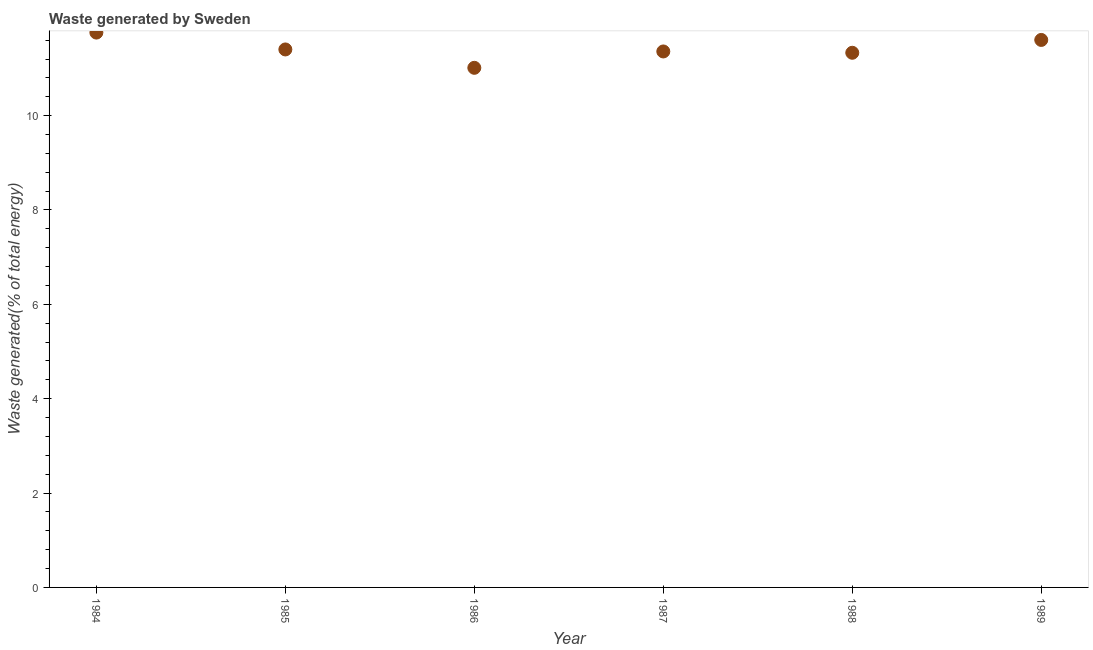What is the amount of waste generated in 1988?
Provide a succinct answer. 11.33. Across all years, what is the maximum amount of waste generated?
Keep it short and to the point. 11.76. Across all years, what is the minimum amount of waste generated?
Your response must be concise. 11.01. In which year was the amount of waste generated maximum?
Give a very brief answer. 1984. In which year was the amount of waste generated minimum?
Offer a terse response. 1986. What is the sum of the amount of waste generated?
Keep it short and to the point. 68.47. What is the difference between the amount of waste generated in 1987 and 1988?
Your answer should be compact. 0.03. What is the average amount of waste generated per year?
Keep it short and to the point. 11.41. What is the median amount of waste generated?
Ensure brevity in your answer.  11.38. Do a majority of the years between 1984 and 1987 (inclusive) have amount of waste generated greater than 0.4 %?
Your answer should be compact. Yes. What is the ratio of the amount of waste generated in 1985 to that in 1989?
Offer a very short reply. 0.98. Is the amount of waste generated in 1984 less than that in 1989?
Your response must be concise. No. What is the difference between the highest and the second highest amount of waste generated?
Your response must be concise. 0.16. What is the difference between the highest and the lowest amount of waste generated?
Offer a very short reply. 0.75. How many years are there in the graph?
Offer a terse response. 6. Does the graph contain any zero values?
Ensure brevity in your answer.  No. Does the graph contain grids?
Your response must be concise. No. What is the title of the graph?
Ensure brevity in your answer.  Waste generated by Sweden. What is the label or title of the X-axis?
Offer a very short reply. Year. What is the label or title of the Y-axis?
Your response must be concise. Waste generated(% of total energy). What is the Waste generated(% of total energy) in 1984?
Provide a short and direct response. 11.76. What is the Waste generated(% of total energy) in 1985?
Provide a short and direct response. 11.4. What is the Waste generated(% of total energy) in 1986?
Your answer should be very brief. 11.01. What is the Waste generated(% of total energy) in 1987?
Offer a terse response. 11.36. What is the Waste generated(% of total energy) in 1988?
Provide a succinct answer. 11.33. What is the Waste generated(% of total energy) in 1989?
Ensure brevity in your answer.  11.6. What is the difference between the Waste generated(% of total energy) in 1984 and 1985?
Provide a short and direct response. 0.36. What is the difference between the Waste generated(% of total energy) in 1984 and 1986?
Provide a short and direct response. 0.75. What is the difference between the Waste generated(% of total energy) in 1984 and 1987?
Give a very brief answer. 0.4. What is the difference between the Waste generated(% of total energy) in 1984 and 1988?
Offer a terse response. 0.43. What is the difference between the Waste generated(% of total energy) in 1984 and 1989?
Keep it short and to the point. 0.16. What is the difference between the Waste generated(% of total energy) in 1985 and 1986?
Provide a short and direct response. 0.39. What is the difference between the Waste generated(% of total energy) in 1985 and 1987?
Make the answer very short. 0.04. What is the difference between the Waste generated(% of total energy) in 1985 and 1988?
Provide a short and direct response. 0.07. What is the difference between the Waste generated(% of total energy) in 1985 and 1989?
Keep it short and to the point. -0.2. What is the difference between the Waste generated(% of total energy) in 1986 and 1987?
Ensure brevity in your answer.  -0.35. What is the difference between the Waste generated(% of total energy) in 1986 and 1988?
Provide a short and direct response. -0.32. What is the difference between the Waste generated(% of total energy) in 1986 and 1989?
Keep it short and to the point. -0.59. What is the difference between the Waste generated(% of total energy) in 1987 and 1988?
Offer a very short reply. 0.03. What is the difference between the Waste generated(% of total energy) in 1987 and 1989?
Offer a terse response. -0.24. What is the difference between the Waste generated(% of total energy) in 1988 and 1989?
Your response must be concise. -0.27. What is the ratio of the Waste generated(% of total energy) in 1984 to that in 1985?
Your answer should be compact. 1.03. What is the ratio of the Waste generated(% of total energy) in 1984 to that in 1986?
Offer a very short reply. 1.07. What is the ratio of the Waste generated(% of total energy) in 1984 to that in 1987?
Provide a short and direct response. 1.03. What is the ratio of the Waste generated(% of total energy) in 1984 to that in 1988?
Provide a succinct answer. 1.04. What is the ratio of the Waste generated(% of total energy) in 1984 to that in 1989?
Ensure brevity in your answer.  1.01. What is the ratio of the Waste generated(% of total energy) in 1985 to that in 1986?
Keep it short and to the point. 1.03. What is the ratio of the Waste generated(% of total energy) in 1985 to that in 1987?
Make the answer very short. 1. What is the ratio of the Waste generated(% of total energy) in 1985 to that in 1988?
Offer a very short reply. 1.01. What is the ratio of the Waste generated(% of total energy) in 1985 to that in 1989?
Make the answer very short. 0.98. What is the ratio of the Waste generated(% of total energy) in 1986 to that in 1988?
Provide a succinct answer. 0.97. What is the ratio of the Waste generated(% of total energy) in 1986 to that in 1989?
Provide a succinct answer. 0.95. What is the ratio of the Waste generated(% of total energy) in 1987 to that in 1989?
Offer a terse response. 0.98. What is the ratio of the Waste generated(% of total energy) in 1988 to that in 1989?
Your answer should be very brief. 0.98. 